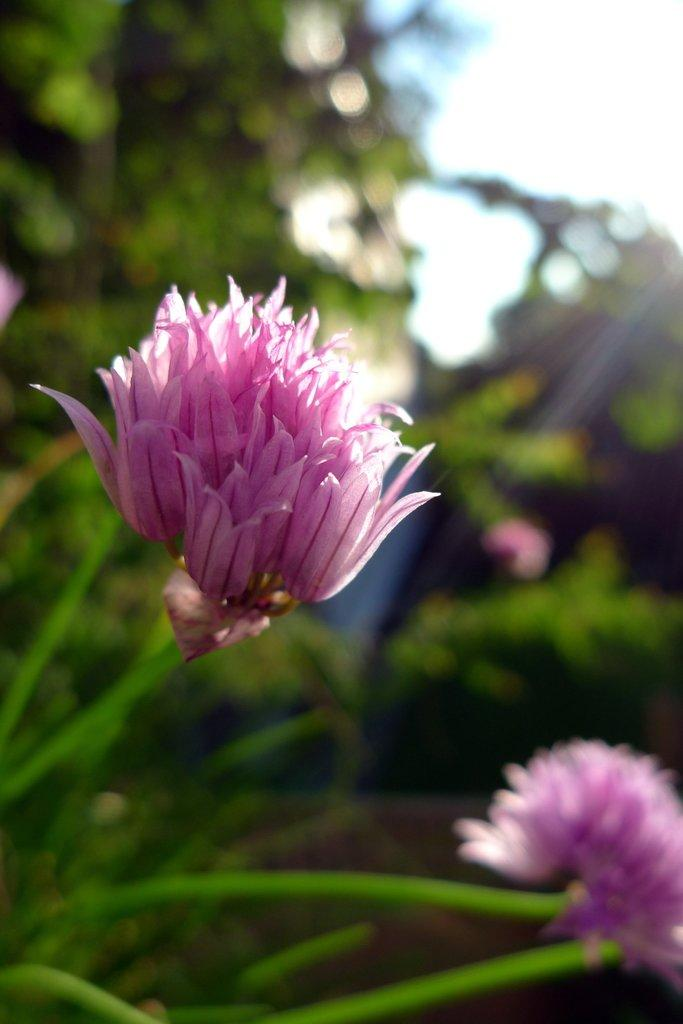What type of plants are in the image? There are flowers with stems in the image. Where are the flowers located in the image? The flowers are in the middle of the image. What can be seen in the background of the image? There are trees in the background of the image. What type of vacation is being taken in the image? There is no indication of a vacation in the image; it features flowers with stems in the middle of the image and trees in the background. 